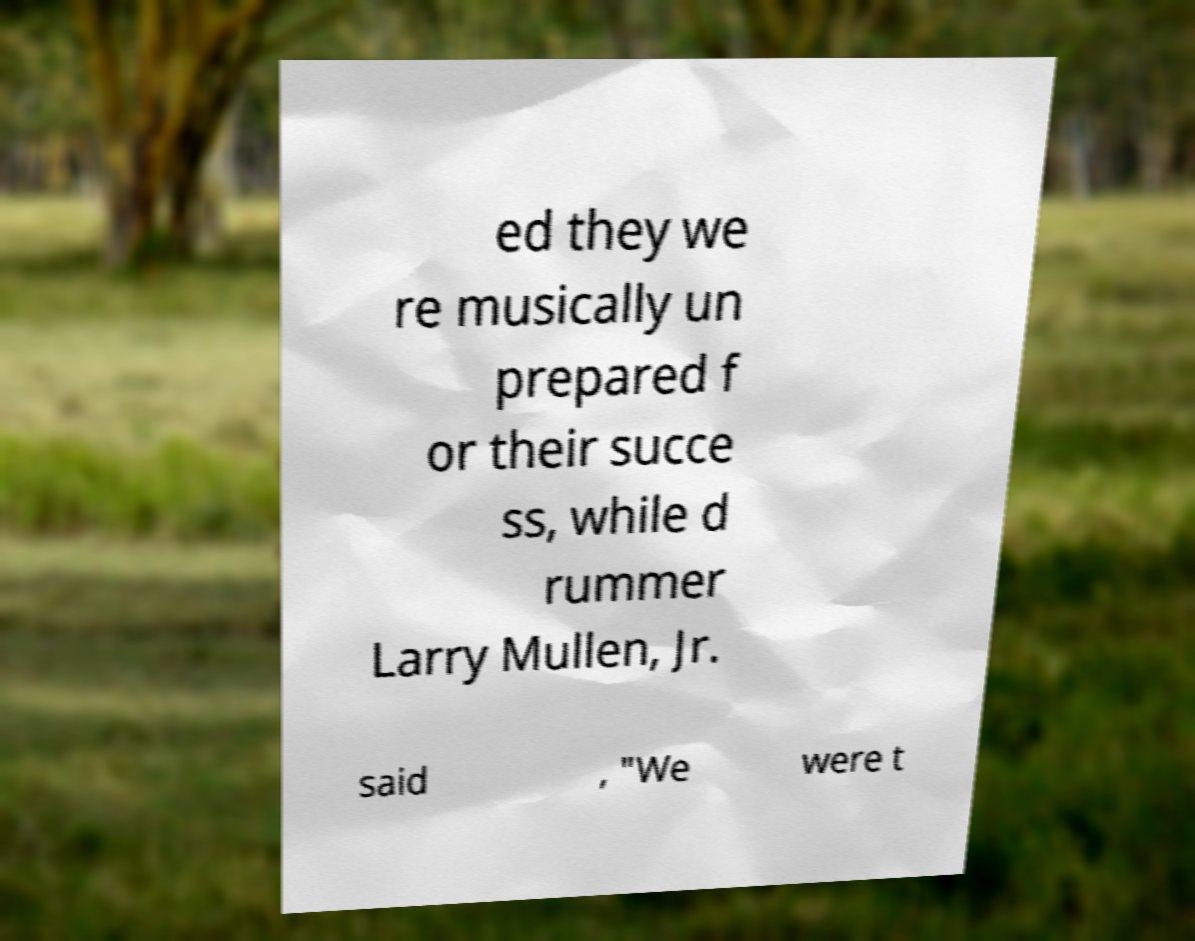Could you extract and type out the text from this image? ed they we re musically un prepared f or their succe ss, while d rummer Larry Mullen, Jr. said , "We were t 